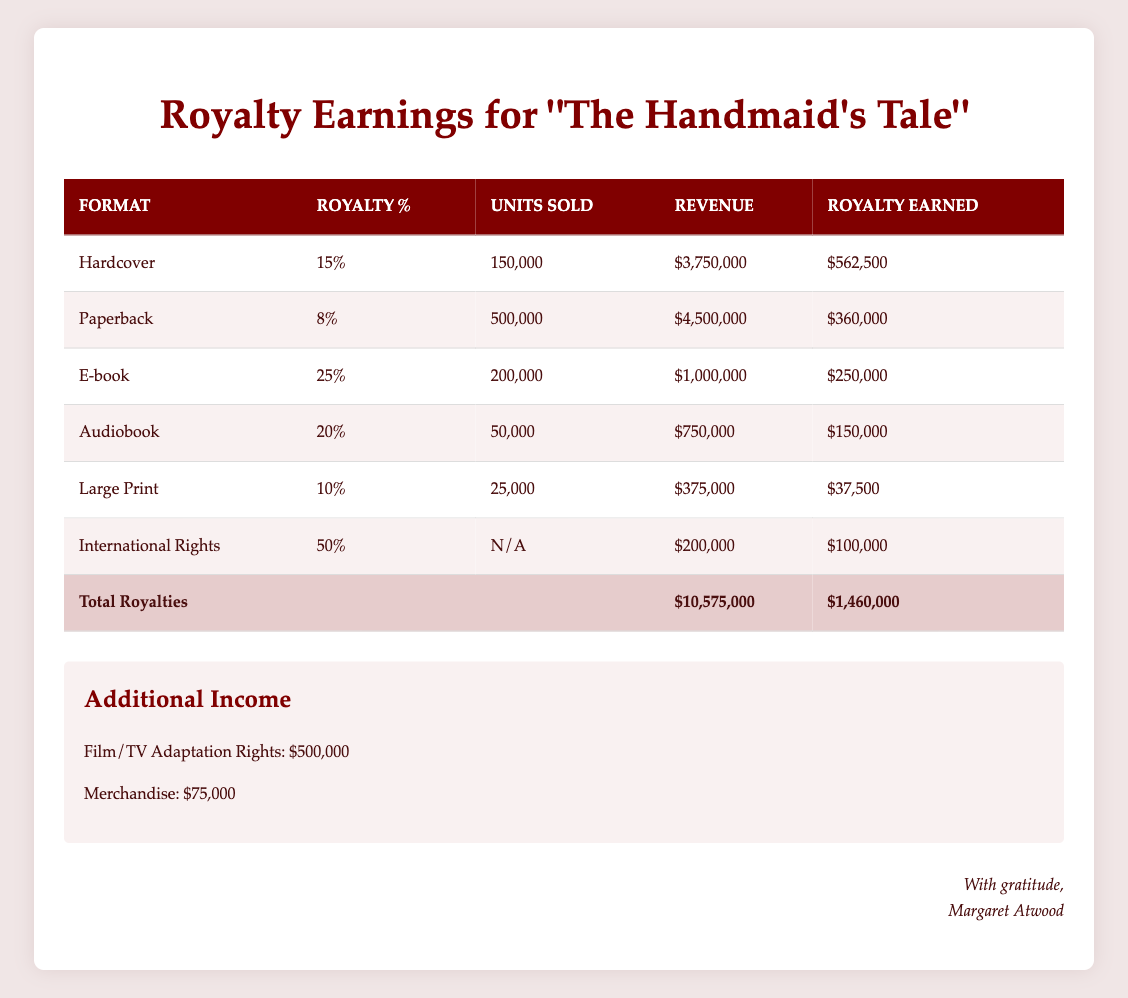What is the total revenue generated from the paperback format? From the table, the revenue from the paperback format is listed as $4,500,000.
Answer: $4,500,000 Which format earned the most in royalties? By comparing the 'royalty earned' values, we find that the hardcover format earned $562,500, paperback earned $360,000, e-book earned $250,000, audiobook earned $150,000, large print earned $37,500, and international rights earned $100,000. The highest value is for the hardcover format.
Answer: Hardcover Is the royalty percentage for the large print format higher than the paperback format? The royalty percentage for the large print format is 10%, while the percentage for the paperback format is 8%. Since 10% is greater than 8%, the answer is yes.
Answer: Yes What is the combined royalty earned from e-books and audiobooks? The royalty earned from e-books is $250,000 and from audiobooks is $150,000. Adding these two amounts gives $250,000 + $150,000 = $400,000.
Answer: $400,000 Did international rights generate more income than the hardcover format? The royalty earned from international rights is $100,000, while the hardcover format earned $562,500. Since $100,000 is less than $562,500, the answer is no.
Answer: No What is the average royalty percentage across all formats listed? The royalty percentages are: 15%, 8%, 25%, 20%, 10%, and 50%. Adding these gives a total of 128%. Dividing this by the total number of formats (6) gives an average of 128% / 6 = 21.33%.
Answer: 21.33% How much additional income was earned from film/TV adaptation rights? The table states that the income from film/TV adaptation rights is $500,000.
Answer: $500,000 Which format sold the highest number of units? The paperback format sold 500,000 units, which is more than the 150,000 units for hardcover, 200,000 for e-books, 50,000 for audiobooks, 25,000 for large print, and no units for international rights. Thus, the highest number of units sold is for paperback.
Answer: Paperback What is the total royalty amount from all formats combined? The royalties earned from each format are: hardcover $562,500, paperback $360,000, e-book $250,000, audiobook $150,000, large print $37,500, and international rights $100,000. The total is calculated as $562,500 + $360,000 + $250,000 + $150,000 + $37,500 + $100,000 = $1,460,000.
Answer: $1,460,000 